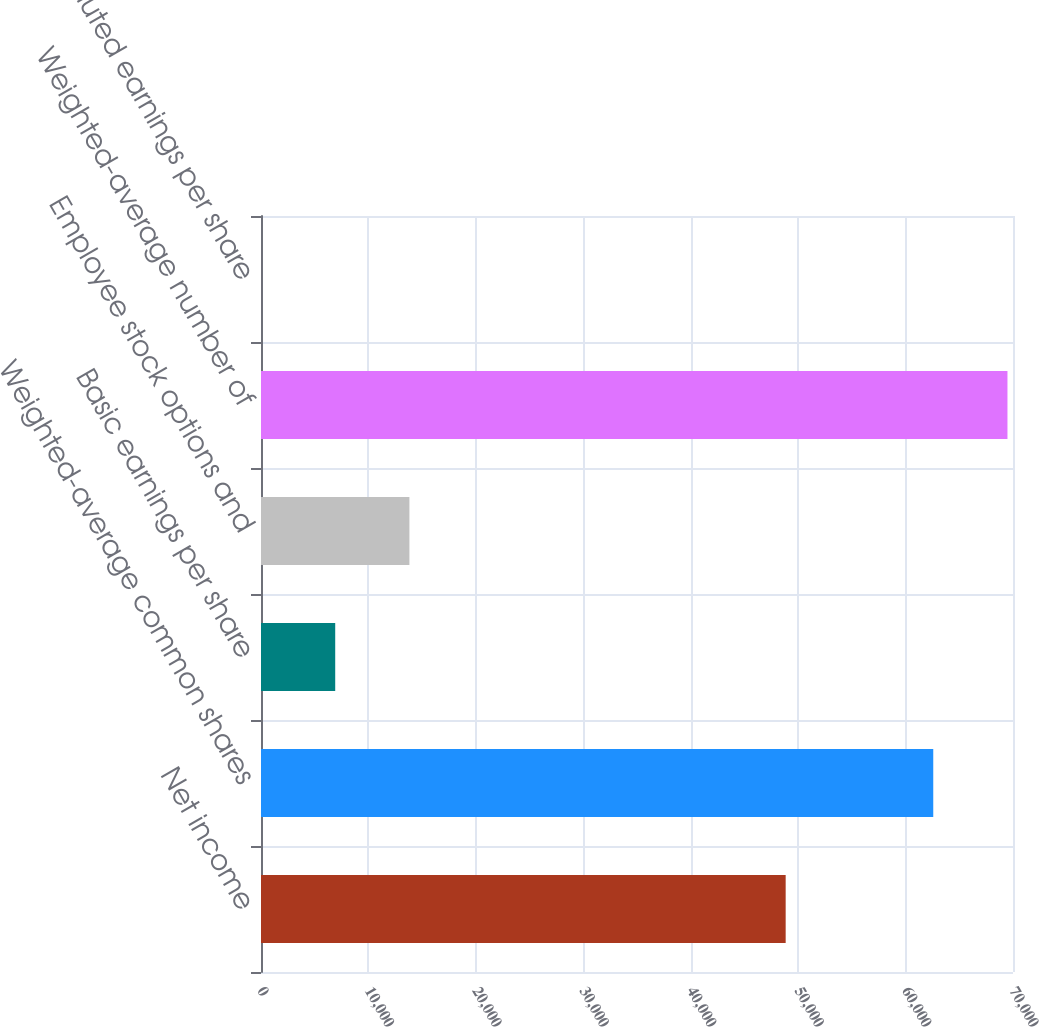Convert chart. <chart><loc_0><loc_0><loc_500><loc_500><bar_chart><fcel>Net income<fcel>Weighted-average common shares<fcel>Basic earnings per share<fcel>Employee stock options and<fcel>Weighted-average number of<fcel>Diluted earnings per share<nl><fcel>48839<fcel>62577<fcel>6908.14<fcel>13815.6<fcel>69484.4<fcel>0.71<nl></chart> 